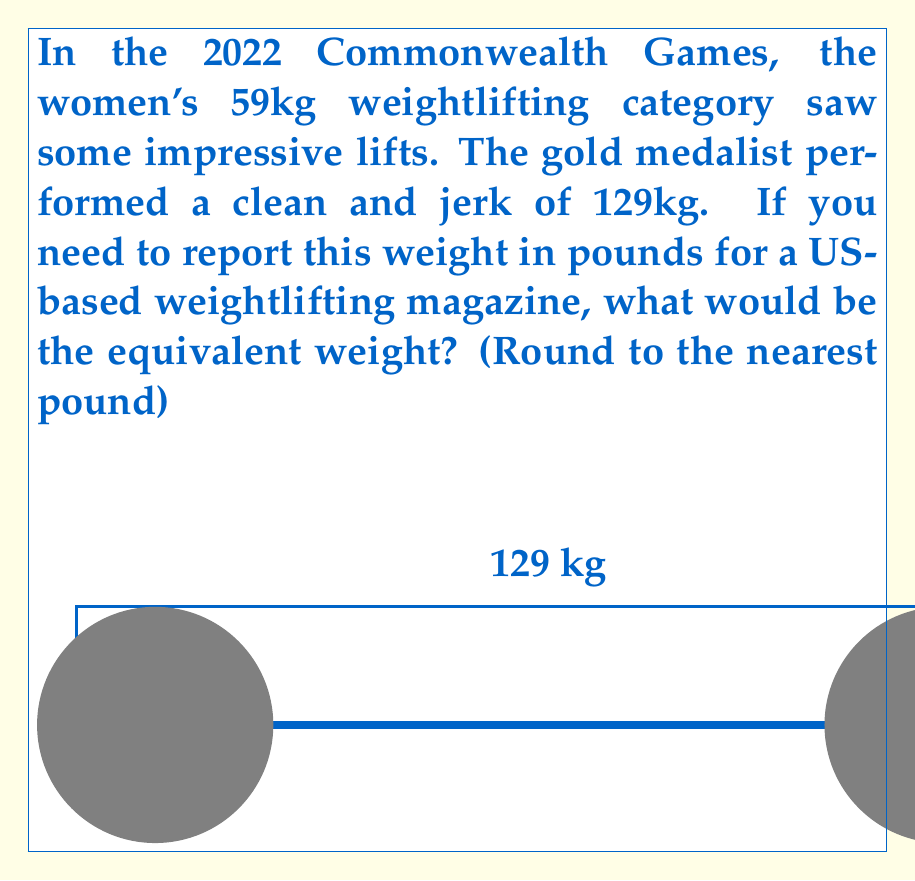Can you solve this math problem? To convert the weight from kilograms to pounds, we need to follow these steps:

1) The conversion factor between kilograms and pounds is:
   $1 \text{ kg} = 2.20462 \text{ lbs}$

2) We need to multiply the given weight in kg by this factor:

   $$129 \text{ kg} \times 2.20462 \frac{\text{lbs}}{\text{kg}} = 284.39598 \text{ lbs}$$

3) The question asks to round to the nearest pound, so we need to round 284.39598 to the nearest whole number.

4) Since the decimal part (0.39598) is less than 0.5, we round down to 284 lbs.

Therefore, the 129 kg clean and jerk is equivalent to 284 lbs when rounded to the nearest pound.
Answer: 284 lbs 